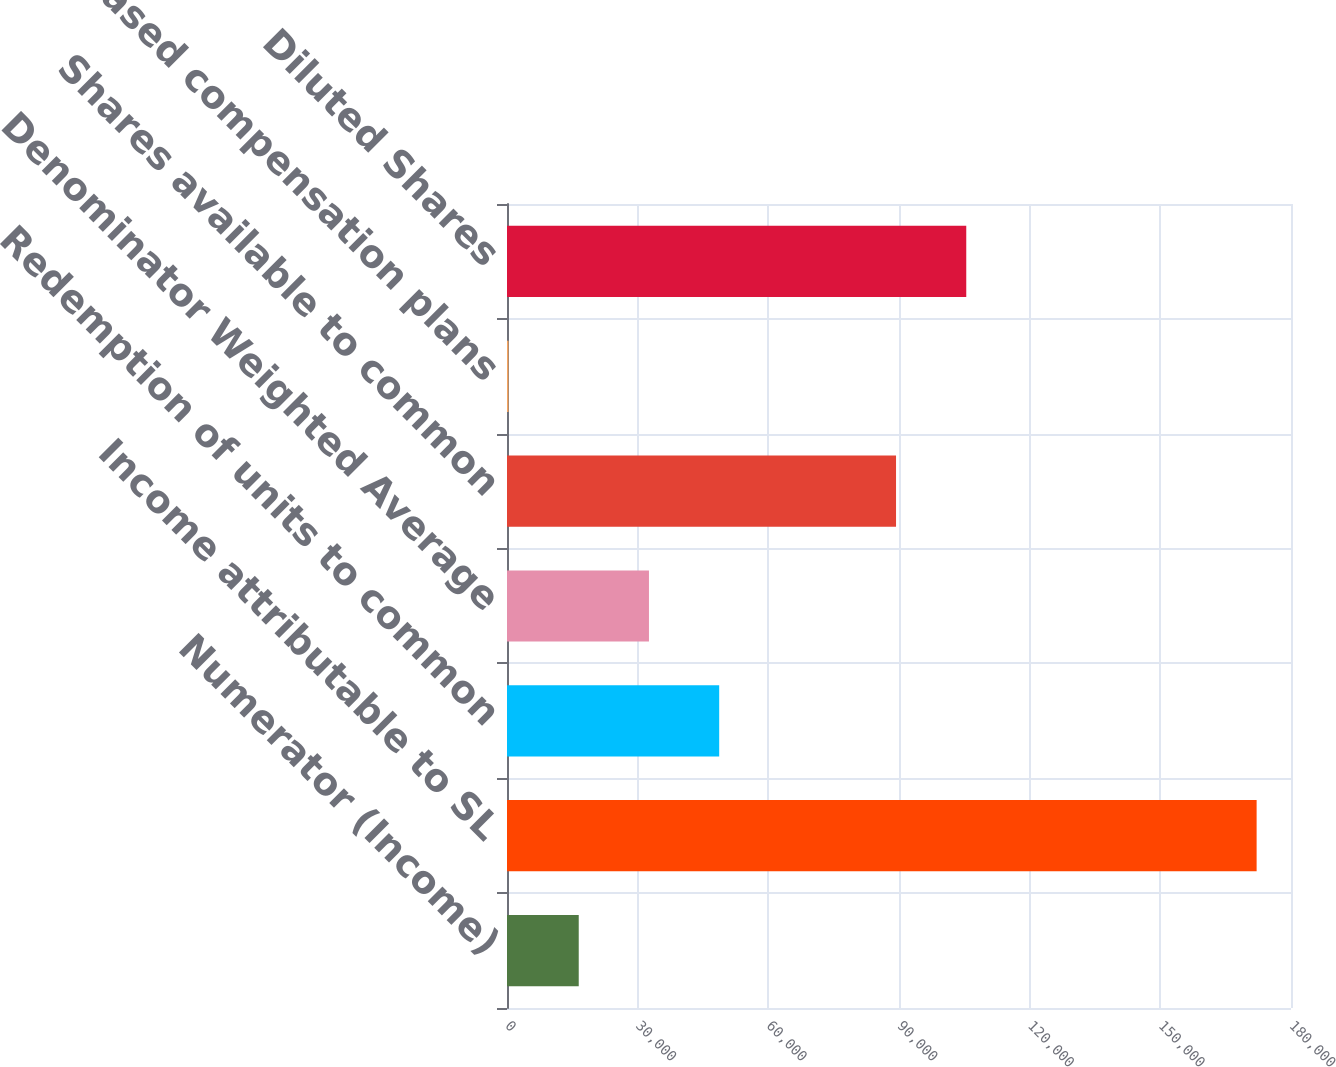Convert chart. <chart><loc_0><loc_0><loc_500><loc_500><bar_chart><fcel>Numerator (Income)<fcel>Income attributable to SL<fcel>Redemption of units to common<fcel>Denominator Weighted Average<fcel>Shares available to common<fcel>Stock based compensation plans<fcel>Diluted Shares<nl><fcel>16470.4<fcel>172107<fcel>48717.2<fcel>32593.8<fcel>89319<fcel>347<fcel>105442<nl></chart> 